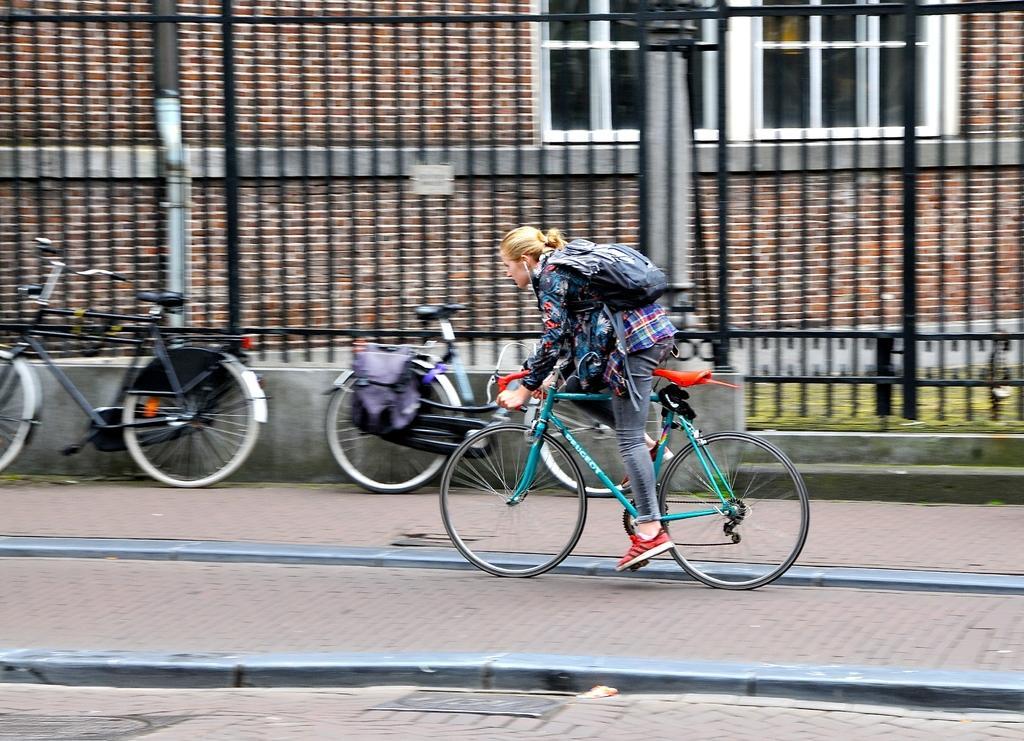Describe this image in one or two sentences. A woman is wearing a bag and riding a cycle through the sidewalk. In the background there are railings, buildings, windows. Two cycles are parked near the railings. 